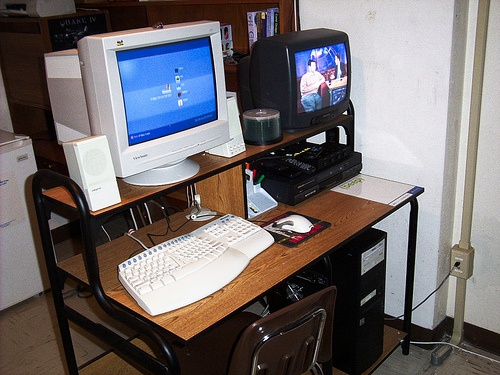Describe the objects in this image and their specific colors. I can see tv in black, lightgray, darkgray, lightblue, and blue tones, tv in black, lavender, gray, and lightblue tones, keyboard in black, white, darkgray, and lightgray tones, refrigerator in black and gray tones, and chair in black and gray tones in this image. 